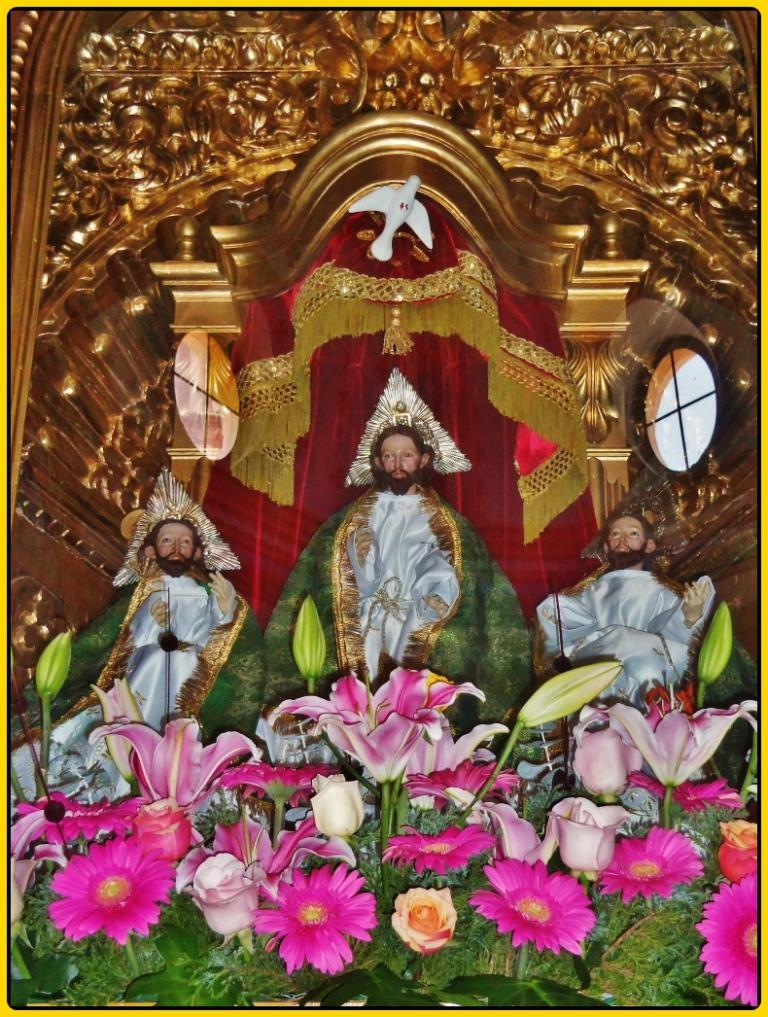What is depicted in the image? There are statues of three persons in the image. Are there any other elements in the image besides the statues? Yes, there are flowering plants and curtains in the image. What type of object is the image contained within? The image appears to be a photo frame. Is the unit in the image filled with quicksand? There is no unit filled with quicksand present in the image; it features statues, flowering plants, and curtains in a photo frame. What type of paint is used on the statues in the image? There is no information about the type of paint used on the statues in the image, as the focus is on the subjects and elements present. 